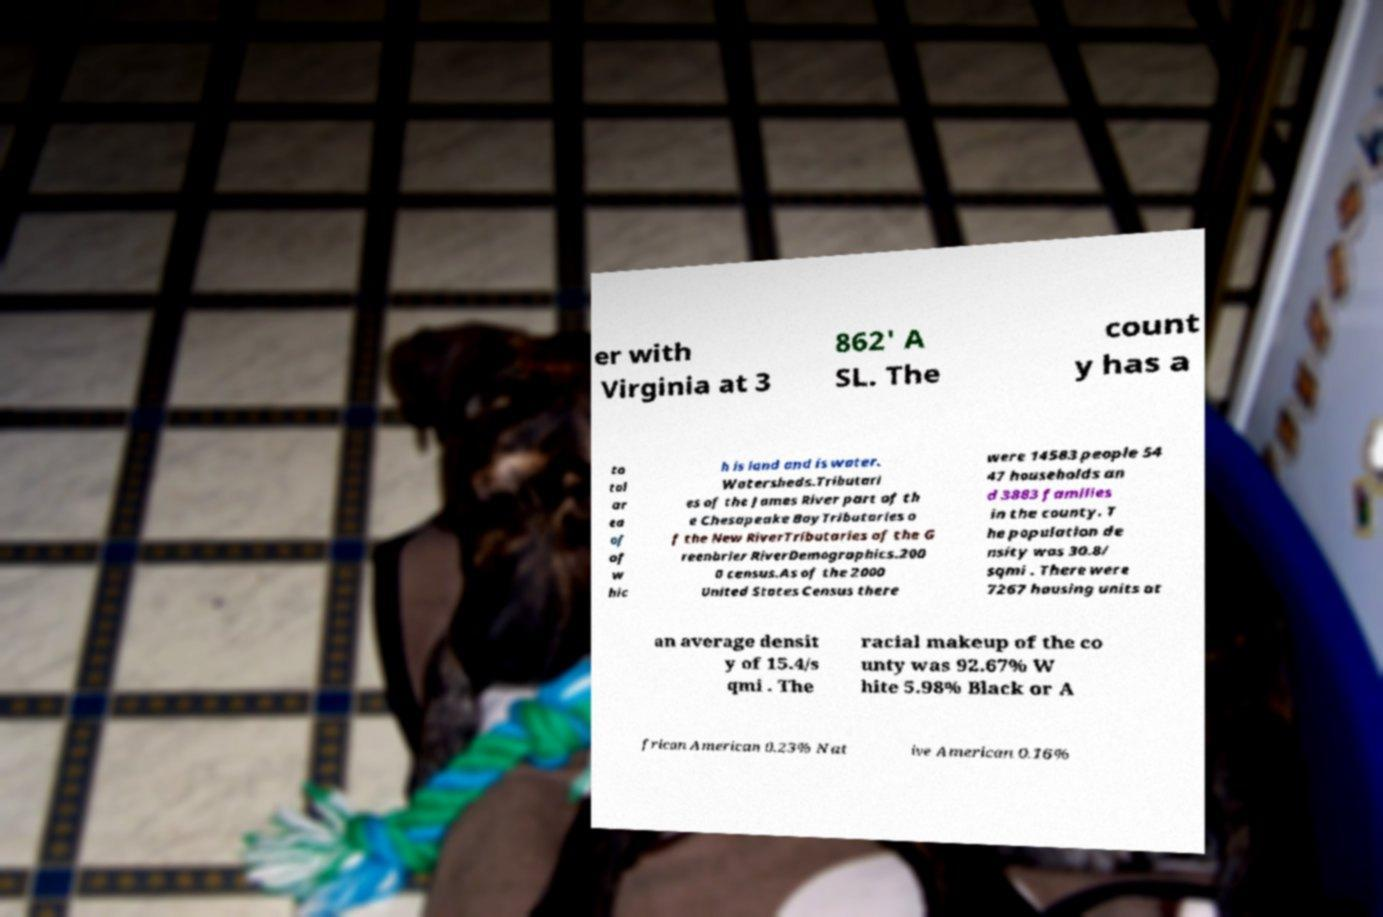Can you accurately transcribe the text from the provided image for me? er with Virginia at 3 862' A SL. The count y has a to tal ar ea of of w hic h is land and is water. Watersheds.Tributari es of the James River part of th e Chesapeake BayTributaries o f the New RiverTributaries of the G reenbrier RiverDemographics.200 0 census.As of the 2000 United States Census there were 14583 people 54 47 households an d 3883 families in the county. T he population de nsity was 30.8/ sqmi . There were 7267 housing units at an average densit y of 15.4/s qmi . The racial makeup of the co unty was 92.67% W hite 5.98% Black or A frican American 0.23% Nat ive American 0.16% 